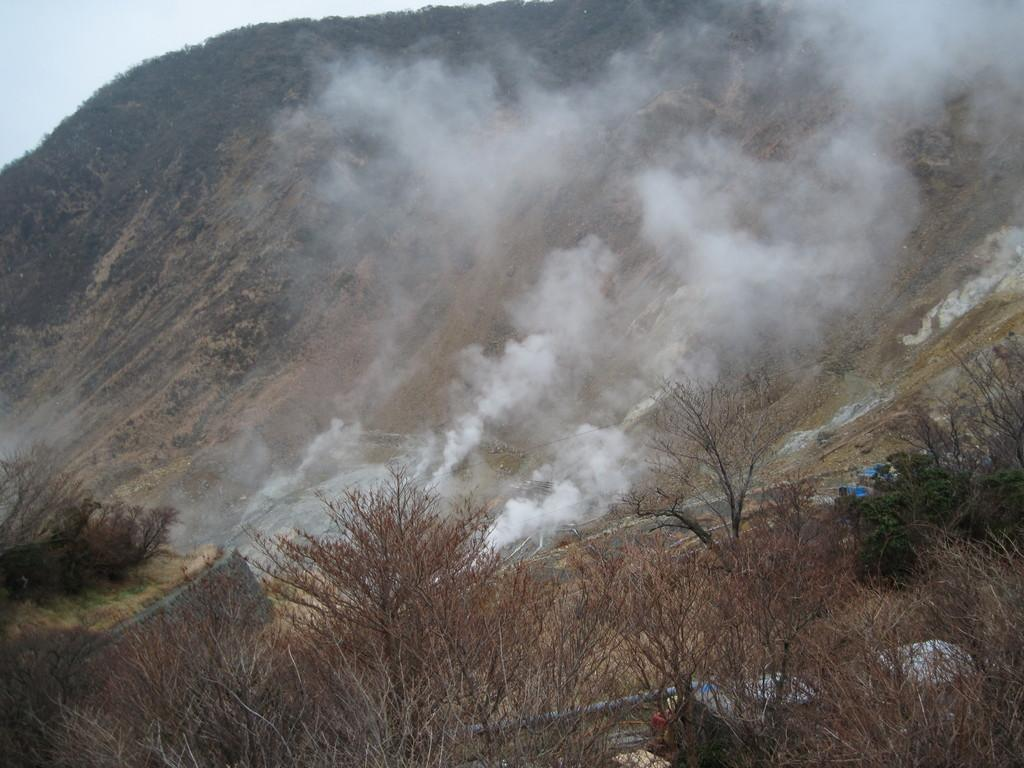What type of natural elements can be seen in the image? There are trees in the image. What is present on the ground in the image? There are objects on the ground in the image. What is the source of the smoke visible in the image? The source of the smoke is not specified in the image. What can be seen in the background of the image? The sky is visible in the background of the image. What type of card can be seen in the image? There is no card present in the image. What is the texture of the bath in the image? There is no bath present in the image. 